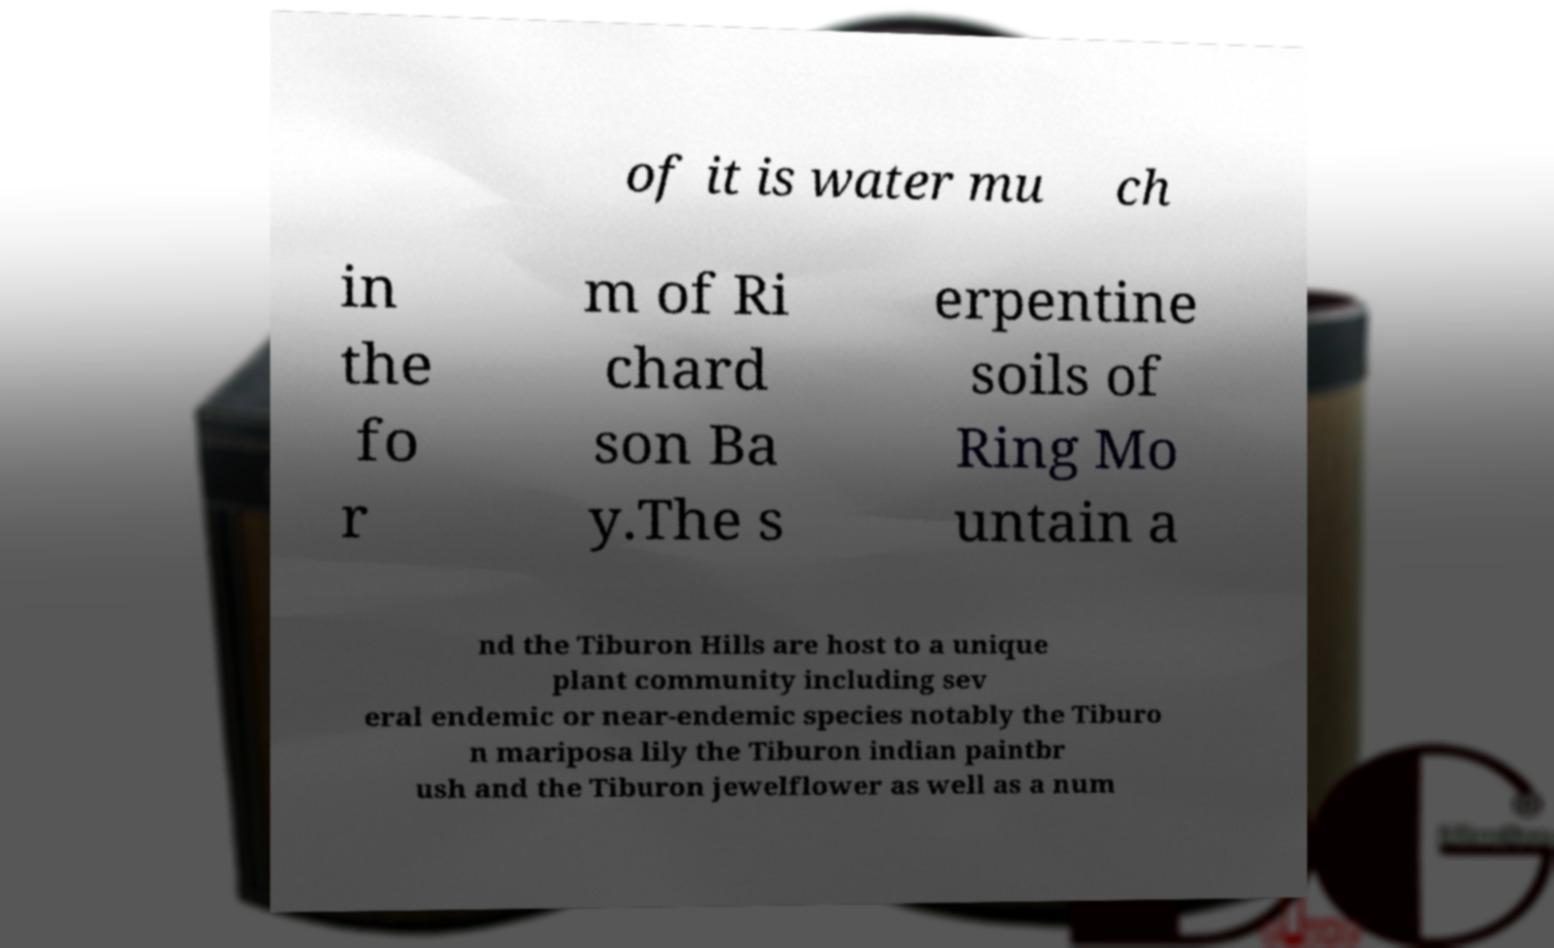For documentation purposes, I need the text within this image transcribed. Could you provide that? of it is water mu ch in the fo r m of Ri chard son Ba y.The s erpentine soils of Ring Mo untain a nd the Tiburon Hills are host to a unique plant community including sev eral endemic or near-endemic species notably the Tiburo n mariposa lily the Tiburon indian paintbr ush and the Tiburon jewelflower as well as a num 